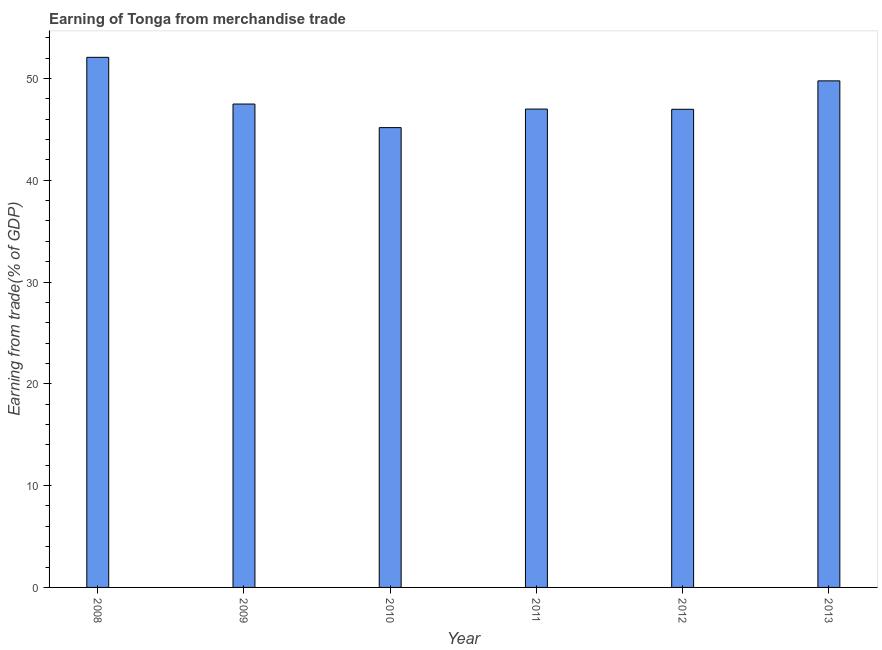What is the title of the graph?
Provide a short and direct response. Earning of Tonga from merchandise trade. What is the label or title of the X-axis?
Your answer should be compact. Year. What is the label or title of the Y-axis?
Keep it short and to the point. Earning from trade(% of GDP). What is the earning from merchandise trade in 2008?
Provide a succinct answer. 52.07. Across all years, what is the maximum earning from merchandise trade?
Your answer should be compact. 52.07. Across all years, what is the minimum earning from merchandise trade?
Your answer should be very brief. 45.17. In which year was the earning from merchandise trade maximum?
Your response must be concise. 2008. What is the sum of the earning from merchandise trade?
Offer a terse response. 288.43. What is the difference between the earning from merchandise trade in 2009 and 2012?
Make the answer very short. 0.52. What is the average earning from merchandise trade per year?
Keep it short and to the point. 48.07. What is the median earning from merchandise trade?
Offer a terse response. 47.23. In how many years, is the earning from merchandise trade greater than 48 %?
Your response must be concise. 2. Do a majority of the years between 2013 and 2012 (inclusive) have earning from merchandise trade greater than 16 %?
Your answer should be very brief. No. What is the difference between the highest and the second highest earning from merchandise trade?
Provide a short and direct response. 2.31. How many bars are there?
Keep it short and to the point. 6. Are all the bars in the graph horizontal?
Provide a short and direct response. No. How many years are there in the graph?
Offer a very short reply. 6. What is the difference between two consecutive major ticks on the Y-axis?
Offer a terse response. 10. What is the Earning from trade(% of GDP) of 2008?
Make the answer very short. 52.07. What is the Earning from trade(% of GDP) of 2009?
Keep it short and to the point. 47.48. What is the Earning from trade(% of GDP) of 2010?
Give a very brief answer. 45.17. What is the Earning from trade(% of GDP) of 2011?
Offer a terse response. 46.99. What is the Earning from trade(% of GDP) of 2012?
Offer a terse response. 46.97. What is the Earning from trade(% of GDP) in 2013?
Provide a succinct answer. 49.76. What is the difference between the Earning from trade(% of GDP) in 2008 and 2009?
Your response must be concise. 4.59. What is the difference between the Earning from trade(% of GDP) in 2008 and 2010?
Your answer should be compact. 6.9. What is the difference between the Earning from trade(% of GDP) in 2008 and 2011?
Provide a short and direct response. 5.08. What is the difference between the Earning from trade(% of GDP) in 2008 and 2012?
Your response must be concise. 5.1. What is the difference between the Earning from trade(% of GDP) in 2008 and 2013?
Ensure brevity in your answer.  2.31. What is the difference between the Earning from trade(% of GDP) in 2009 and 2010?
Give a very brief answer. 2.32. What is the difference between the Earning from trade(% of GDP) in 2009 and 2011?
Provide a succinct answer. 0.49. What is the difference between the Earning from trade(% of GDP) in 2009 and 2012?
Your answer should be very brief. 0.51. What is the difference between the Earning from trade(% of GDP) in 2009 and 2013?
Offer a very short reply. -2.28. What is the difference between the Earning from trade(% of GDP) in 2010 and 2011?
Provide a succinct answer. -1.82. What is the difference between the Earning from trade(% of GDP) in 2010 and 2012?
Offer a very short reply. -1.8. What is the difference between the Earning from trade(% of GDP) in 2010 and 2013?
Your answer should be very brief. -4.59. What is the difference between the Earning from trade(% of GDP) in 2011 and 2012?
Your answer should be compact. 0.02. What is the difference between the Earning from trade(% of GDP) in 2011 and 2013?
Give a very brief answer. -2.77. What is the difference between the Earning from trade(% of GDP) in 2012 and 2013?
Make the answer very short. -2.79. What is the ratio of the Earning from trade(% of GDP) in 2008 to that in 2009?
Keep it short and to the point. 1.1. What is the ratio of the Earning from trade(% of GDP) in 2008 to that in 2010?
Offer a very short reply. 1.15. What is the ratio of the Earning from trade(% of GDP) in 2008 to that in 2011?
Provide a succinct answer. 1.11. What is the ratio of the Earning from trade(% of GDP) in 2008 to that in 2012?
Offer a terse response. 1.11. What is the ratio of the Earning from trade(% of GDP) in 2008 to that in 2013?
Ensure brevity in your answer.  1.05. What is the ratio of the Earning from trade(% of GDP) in 2009 to that in 2010?
Make the answer very short. 1.05. What is the ratio of the Earning from trade(% of GDP) in 2009 to that in 2011?
Provide a short and direct response. 1.01. What is the ratio of the Earning from trade(% of GDP) in 2009 to that in 2012?
Give a very brief answer. 1.01. What is the ratio of the Earning from trade(% of GDP) in 2009 to that in 2013?
Offer a terse response. 0.95. What is the ratio of the Earning from trade(% of GDP) in 2010 to that in 2012?
Your answer should be very brief. 0.96. What is the ratio of the Earning from trade(% of GDP) in 2010 to that in 2013?
Ensure brevity in your answer.  0.91. What is the ratio of the Earning from trade(% of GDP) in 2011 to that in 2012?
Ensure brevity in your answer.  1. What is the ratio of the Earning from trade(% of GDP) in 2011 to that in 2013?
Ensure brevity in your answer.  0.94. What is the ratio of the Earning from trade(% of GDP) in 2012 to that in 2013?
Your response must be concise. 0.94. 